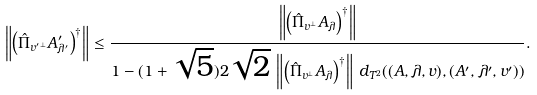Convert formula to latex. <formula><loc_0><loc_0><loc_500><loc_500>\left \| \left ( \hat { \Pi } _ { { v ^ { \prime } } ^ { \perp } } A ^ { \prime } _ { \lambda ^ { \prime } } \right ) ^ { \dagger } \right \| \leq \frac { \left \| \left ( \hat { \Pi } _ { v ^ { \perp } } A _ { \lambda } \right ) ^ { \dagger } \right \| } { 1 - ( 1 + \sqrt { 5 } ) 2 \sqrt { 2 } \, \left \| \left ( \hat { \Pi } _ { v ^ { \perp } } A _ { \lambda } \right ) ^ { \dagger } \right \| \, d _ { T ^ { 2 } } ( ( A , \lambda , v ) , ( A ^ { \prime } , \lambda ^ { \prime } , v ^ { \prime } ) ) } .</formula> 